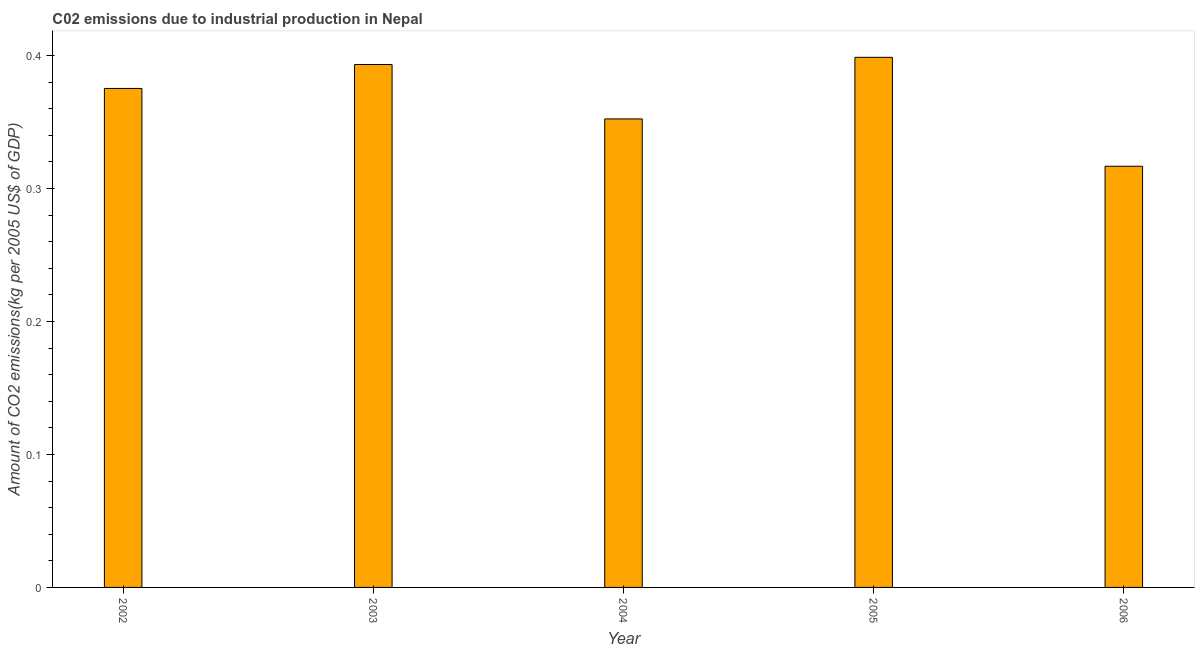Does the graph contain any zero values?
Offer a terse response. No. What is the title of the graph?
Ensure brevity in your answer.  C02 emissions due to industrial production in Nepal. What is the label or title of the Y-axis?
Your response must be concise. Amount of CO2 emissions(kg per 2005 US$ of GDP). What is the amount of co2 emissions in 2004?
Offer a terse response. 0.35. Across all years, what is the maximum amount of co2 emissions?
Your response must be concise. 0.4. Across all years, what is the minimum amount of co2 emissions?
Offer a very short reply. 0.32. What is the sum of the amount of co2 emissions?
Provide a short and direct response. 1.84. What is the difference between the amount of co2 emissions in 2003 and 2006?
Ensure brevity in your answer.  0.08. What is the average amount of co2 emissions per year?
Provide a succinct answer. 0.37. What is the median amount of co2 emissions?
Provide a succinct answer. 0.38. Do a majority of the years between 2003 and 2005 (inclusive) have amount of co2 emissions greater than 0.06 kg per 2005 US$ of GDP?
Ensure brevity in your answer.  Yes. What is the ratio of the amount of co2 emissions in 2003 to that in 2006?
Your answer should be very brief. 1.24. Is the amount of co2 emissions in 2002 less than that in 2006?
Keep it short and to the point. No. Is the difference between the amount of co2 emissions in 2003 and 2006 greater than the difference between any two years?
Offer a terse response. No. What is the difference between the highest and the second highest amount of co2 emissions?
Your response must be concise. 0.01. What is the difference between the highest and the lowest amount of co2 emissions?
Your answer should be compact. 0.08. In how many years, is the amount of co2 emissions greater than the average amount of co2 emissions taken over all years?
Provide a short and direct response. 3. What is the difference between two consecutive major ticks on the Y-axis?
Your answer should be very brief. 0.1. What is the Amount of CO2 emissions(kg per 2005 US$ of GDP) of 2002?
Your response must be concise. 0.38. What is the Amount of CO2 emissions(kg per 2005 US$ of GDP) of 2003?
Make the answer very short. 0.39. What is the Amount of CO2 emissions(kg per 2005 US$ of GDP) in 2004?
Your response must be concise. 0.35. What is the Amount of CO2 emissions(kg per 2005 US$ of GDP) in 2005?
Ensure brevity in your answer.  0.4. What is the Amount of CO2 emissions(kg per 2005 US$ of GDP) of 2006?
Offer a very short reply. 0.32. What is the difference between the Amount of CO2 emissions(kg per 2005 US$ of GDP) in 2002 and 2003?
Your response must be concise. -0.02. What is the difference between the Amount of CO2 emissions(kg per 2005 US$ of GDP) in 2002 and 2004?
Offer a terse response. 0.02. What is the difference between the Amount of CO2 emissions(kg per 2005 US$ of GDP) in 2002 and 2005?
Keep it short and to the point. -0.02. What is the difference between the Amount of CO2 emissions(kg per 2005 US$ of GDP) in 2002 and 2006?
Your answer should be compact. 0.06. What is the difference between the Amount of CO2 emissions(kg per 2005 US$ of GDP) in 2003 and 2004?
Your answer should be compact. 0.04. What is the difference between the Amount of CO2 emissions(kg per 2005 US$ of GDP) in 2003 and 2005?
Provide a short and direct response. -0.01. What is the difference between the Amount of CO2 emissions(kg per 2005 US$ of GDP) in 2003 and 2006?
Your answer should be very brief. 0.08. What is the difference between the Amount of CO2 emissions(kg per 2005 US$ of GDP) in 2004 and 2005?
Ensure brevity in your answer.  -0.05. What is the difference between the Amount of CO2 emissions(kg per 2005 US$ of GDP) in 2004 and 2006?
Provide a succinct answer. 0.04. What is the difference between the Amount of CO2 emissions(kg per 2005 US$ of GDP) in 2005 and 2006?
Provide a succinct answer. 0.08. What is the ratio of the Amount of CO2 emissions(kg per 2005 US$ of GDP) in 2002 to that in 2003?
Give a very brief answer. 0.95. What is the ratio of the Amount of CO2 emissions(kg per 2005 US$ of GDP) in 2002 to that in 2004?
Provide a succinct answer. 1.06. What is the ratio of the Amount of CO2 emissions(kg per 2005 US$ of GDP) in 2002 to that in 2005?
Your response must be concise. 0.94. What is the ratio of the Amount of CO2 emissions(kg per 2005 US$ of GDP) in 2002 to that in 2006?
Give a very brief answer. 1.19. What is the ratio of the Amount of CO2 emissions(kg per 2005 US$ of GDP) in 2003 to that in 2004?
Your answer should be very brief. 1.12. What is the ratio of the Amount of CO2 emissions(kg per 2005 US$ of GDP) in 2003 to that in 2005?
Keep it short and to the point. 0.99. What is the ratio of the Amount of CO2 emissions(kg per 2005 US$ of GDP) in 2003 to that in 2006?
Make the answer very short. 1.24. What is the ratio of the Amount of CO2 emissions(kg per 2005 US$ of GDP) in 2004 to that in 2005?
Provide a short and direct response. 0.88. What is the ratio of the Amount of CO2 emissions(kg per 2005 US$ of GDP) in 2004 to that in 2006?
Keep it short and to the point. 1.11. What is the ratio of the Amount of CO2 emissions(kg per 2005 US$ of GDP) in 2005 to that in 2006?
Provide a short and direct response. 1.26. 